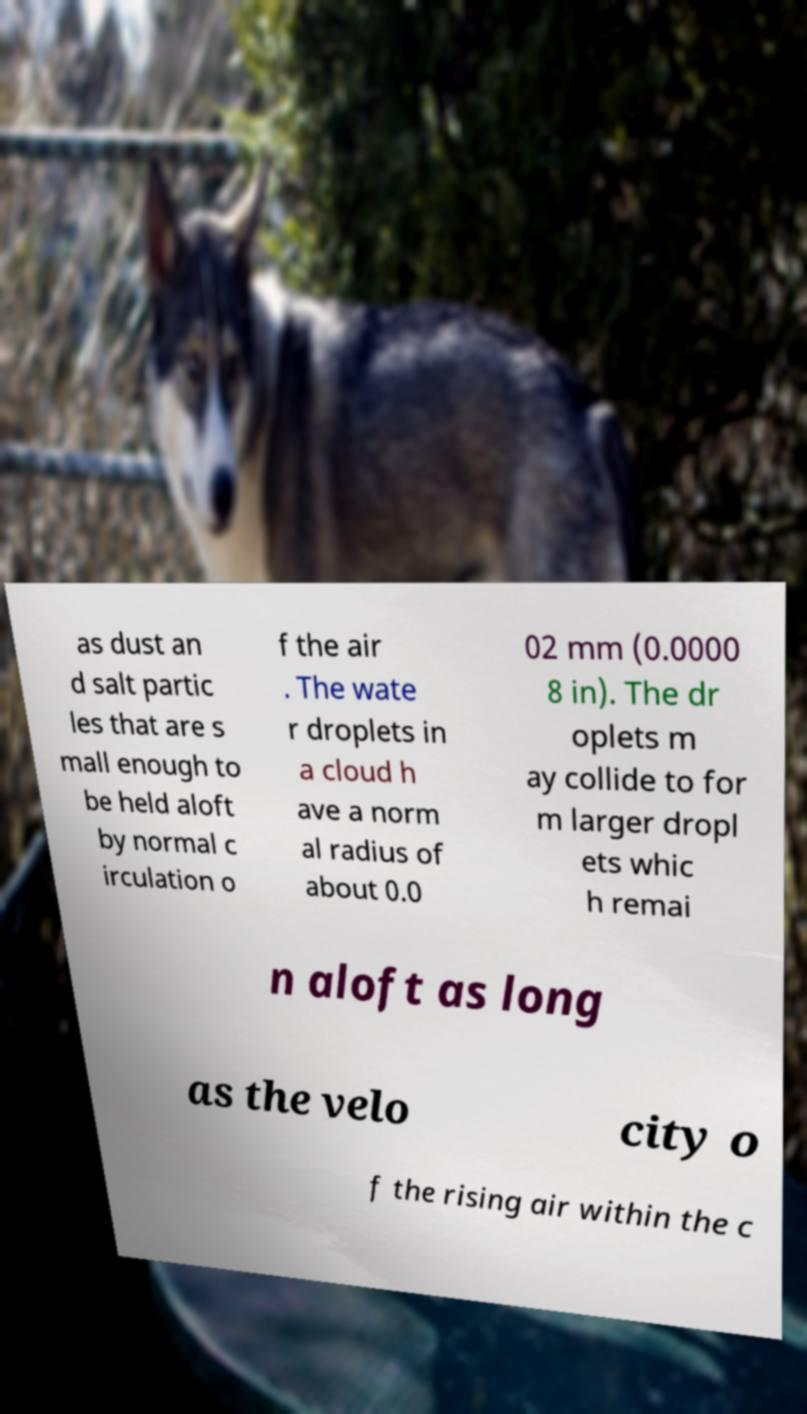For documentation purposes, I need the text within this image transcribed. Could you provide that? as dust an d salt partic les that are s mall enough to be held aloft by normal c irculation o f the air . The wate r droplets in a cloud h ave a norm al radius of about 0.0 02 mm (0.0000 8 in). The dr oplets m ay collide to for m larger dropl ets whic h remai n aloft as long as the velo city o f the rising air within the c 